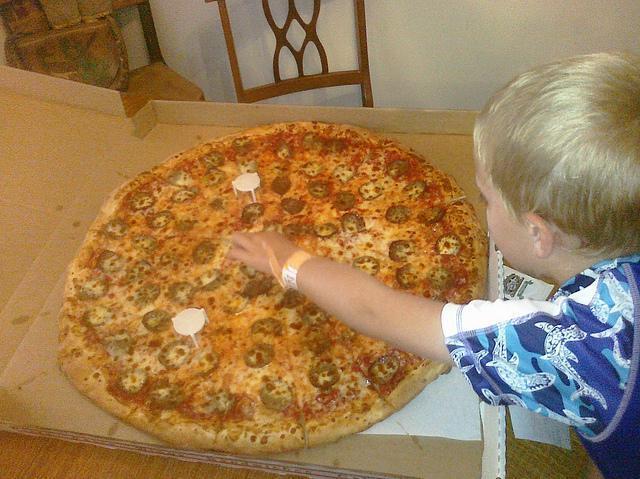How many chairs can be seen?
Give a very brief answer. 2. How many cares are to the left of the bike rider?
Give a very brief answer. 0. 